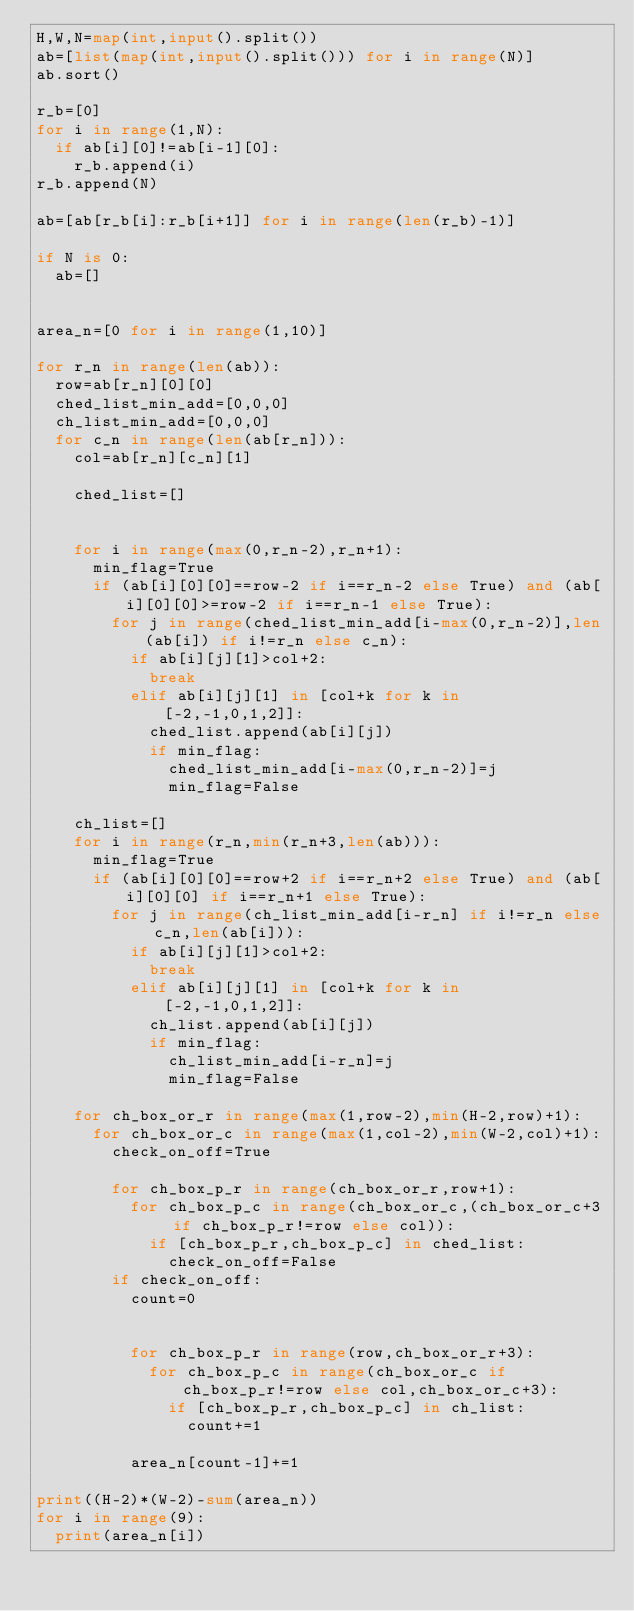<code> <loc_0><loc_0><loc_500><loc_500><_Python_>H,W,N=map(int,input().split())
ab=[list(map(int,input().split())) for i in range(N)]
ab.sort()

r_b=[0]
for i in range(1,N):
  if ab[i][0]!=ab[i-1][0]:
    r_b.append(i)
r_b.append(N)

ab=[ab[r_b[i]:r_b[i+1]] for i in range(len(r_b)-1)]

if N is 0:
  ab=[]


area_n=[0 for i in range(1,10)]  
  
for r_n in range(len(ab)):
  row=ab[r_n][0][0]
  ched_list_min_add=[0,0,0]
  ch_list_min_add=[0,0,0]
  for c_n in range(len(ab[r_n])):
    col=ab[r_n][c_n][1]
    
    ched_list=[]

    
    for i in range(max(0,r_n-2),r_n+1):
      min_flag=True
      if (ab[i][0][0]==row-2 if i==r_n-2 else True) and (ab[i][0][0]>=row-2 if i==r_n-1 else True):
        for j in range(ched_list_min_add[i-max(0,r_n-2)],len(ab[i]) if i!=r_n else c_n):
          if ab[i][j][1]>col+2:
            break
          elif ab[i][j][1] in [col+k for k in [-2,-1,0,1,2]]:
            ched_list.append(ab[i][j])
            if min_flag:
              ched_list_min_add[i-max(0,r_n-2)]=j
              min_flag=False
            
    ch_list=[]    
    for i in range(r_n,min(r_n+3,len(ab))):
      min_flag=True
      if (ab[i][0][0]==row+2 if i==r_n+2 else True) and (ab[i][0][0] if i==r_n+1 else True):
        for j in range(ch_list_min_add[i-r_n] if i!=r_n else c_n,len(ab[i])):
          if ab[i][j][1]>col+2:
            break
          elif ab[i][j][1] in [col+k for k in [-2,-1,0,1,2]]:
            ch_list.append(ab[i][j])
            if min_flag:
              ch_list_min_add[i-r_n]=j
              min_flag=False
      
    for ch_box_or_r in range(max(1,row-2),min(H-2,row)+1):
      for ch_box_or_c in range(max(1,col-2),min(W-2,col)+1):      
        check_on_off=True
       
        for ch_box_p_r in range(ch_box_or_r,row+1):
          for ch_box_p_c in range(ch_box_or_c,(ch_box_or_c+3 if ch_box_p_r!=row else col)):
            if [ch_box_p_r,ch_box_p_c] in ched_list:
              check_on_off=False
        if check_on_off:
          count=0
          
         
          for ch_box_p_r in range(row,ch_box_or_r+3):
            for ch_box_p_c in range(ch_box_or_c if ch_box_p_r!=row else col,ch_box_or_c+3):
              if [ch_box_p_r,ch_box_p_c] in ch_list:
                count+=1
                
          area_n[count-1]+=1
          
print((H-2)*(W-2)-sum(area_n))
for i in range(9):
  print(area_n[i])</code> 